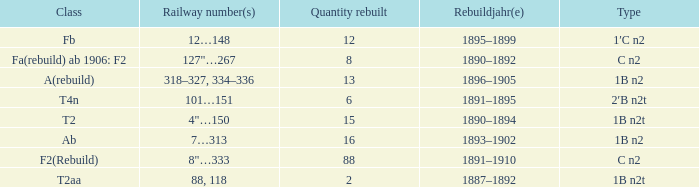What is the total of quantity rebuilt if the type is 1B N2T and the railway number is 88, 118? 1.0. 